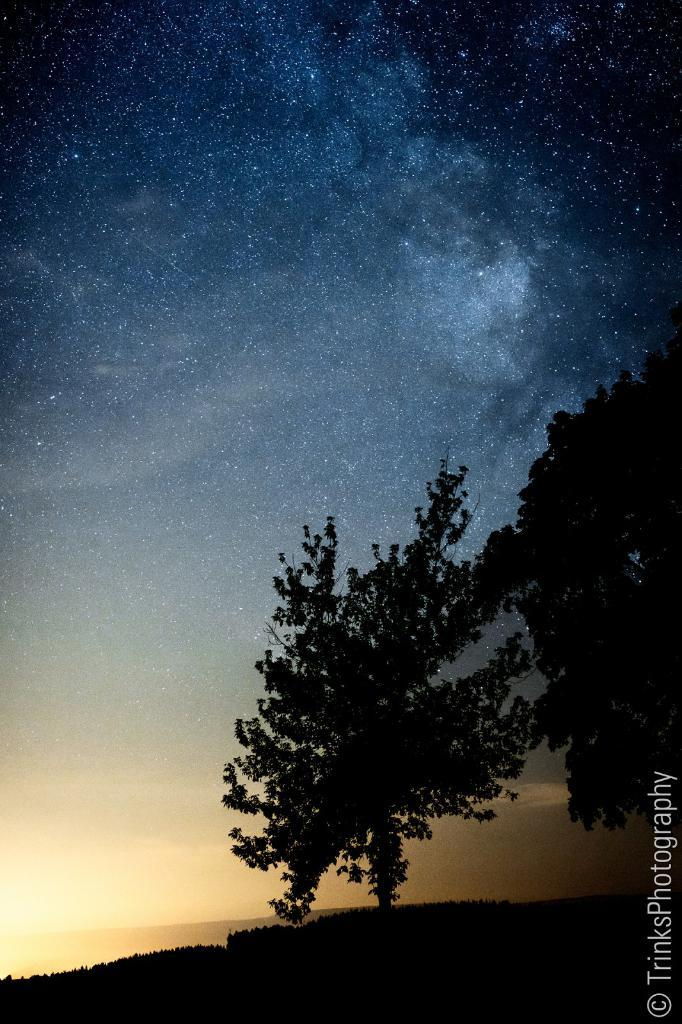What type of natural elements can be seen in the image? There are trees in the image. What else can be seen on the ground in the image? There is ground visible in the image. Are there any words or letters in the image? Yes, there is text present in the image. What can be observed in the bottom left part of the image? The bottom left part of the image shows a sunset. What is visible at the top of the image? The sky is visible at the top of the image. What type of manager is shown in the image? There is no manager present in the image. Can you see a zipper on any of the trees in the image? There are no zippers present on the trees in the image. 